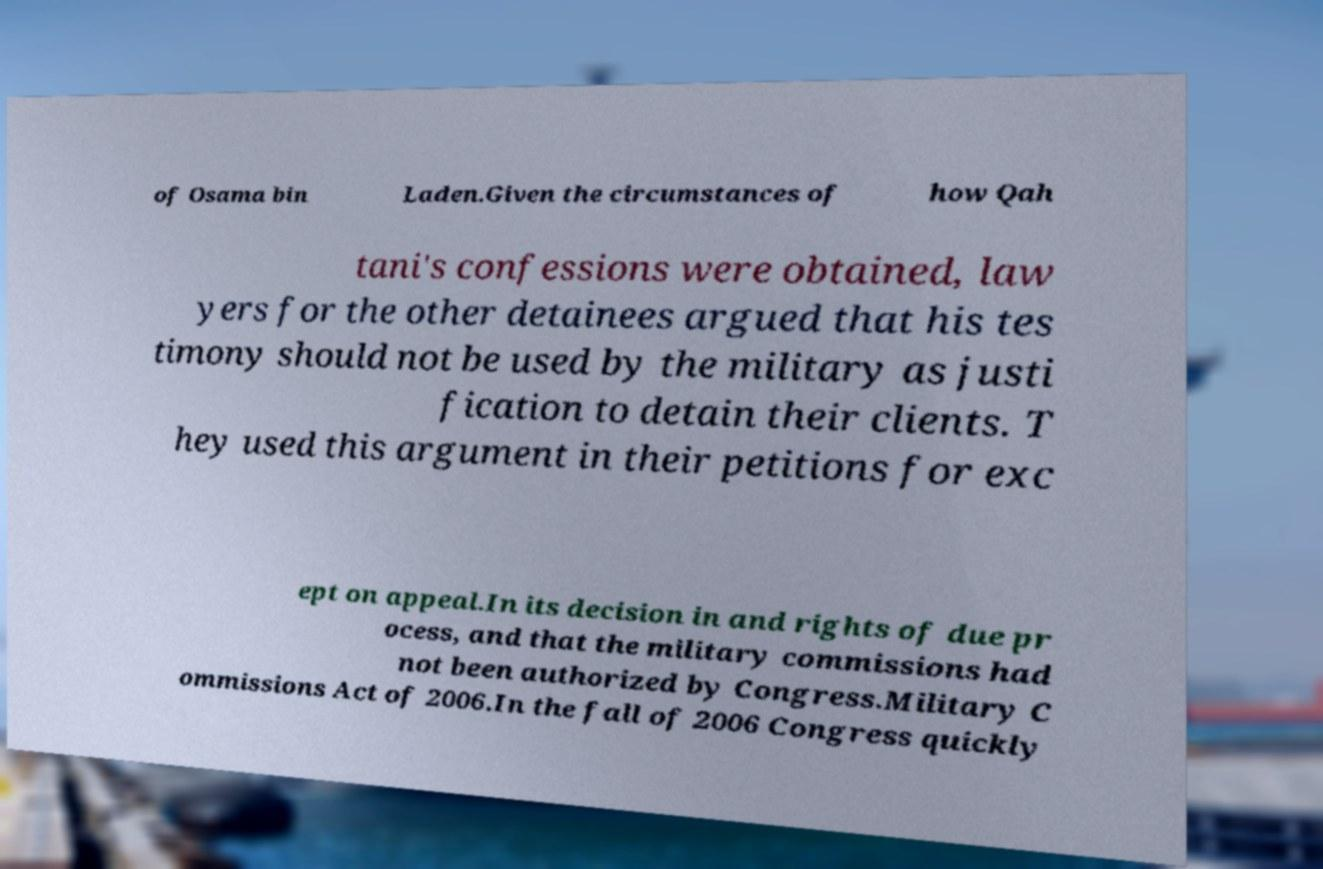Could you assist in decoding the text presented in this image and type it out clearly? of Osama bin Laden.Given the circumstances of how Qah tani's confessions were obtained, law yers for the other detainees argued that his tes timony should not be used by the military as justi fication to detain their clients. T hey used this argument in their petitions for exc ept on appeal.In its decision in and rights of due pr ocess, and that the military commissions had not been authorized by Congress.Military C ommissions Act of 2006.In the fall of 2006 Congress quickly 